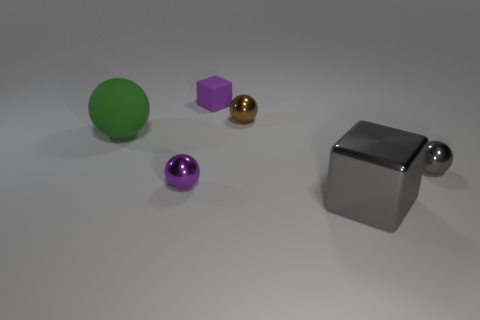Subtract all blue spheres. Subtract all green cubes. How many spheres are left? 4 Add 2 big green spheres. How many objects exist? 8 Subtract all blocks. How many objects are left? 4 Subtract 0 brown cubes. How many objects are left? 6 Subtract all large brown cylinders. Subtract all tiny matte things. How many objects are left? 5 Add 4 large green matte balls. How many large green matte balls are left? 5 Add 2 small purple blocks. How many small purple blocks exist? 3 